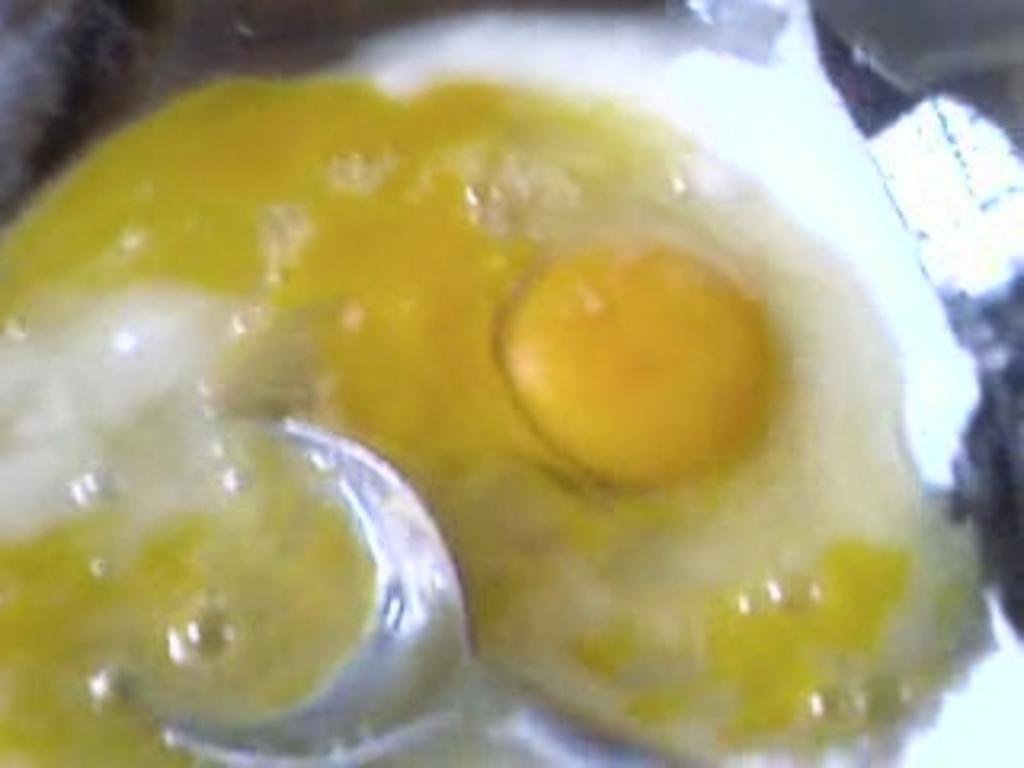What is the main subject of the image? The main subject of the image is food in the center. What utensil is present in the image? There is a spoon in the center of the image. What design is featured on the basketball in the image? There is no basketball present in the image. How does the grandmother interact with the food in the image? There is no grandmother present in the image. 